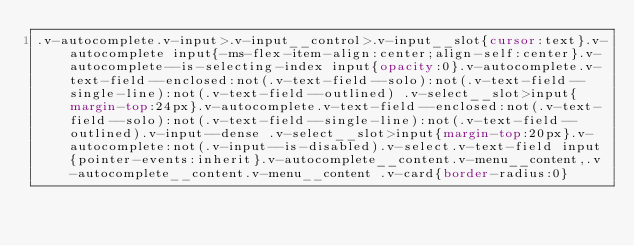Convert code to text. <code><loc_0><loc_0><loc_500><loc_500><_CSS_>.v-autocomplete.v-input>.v-input__control>.v-input__slot{cursor:text}.v-autocomplete input{-ms-flex-item-align:center;align-self:center}.v-autocomplete--is-selecting-index input{opacity:0}.v-autocomplete.v-text-field--enclosed:not(.v-text-field--solo):not(.v-text-field--single-line):not(.v-text-field--outlined) .v-select__slot>input{margin-top:24px}.v-autocomplete.v-text-field--enclosed:not(.v-text-field--solo):not(.v-text-field--single-line):not(.v-text-field--outlined).v-input--dense .v-select__slot>input{margin-top:20px}.v-autocomplete:not(.v-input--is-disabled).v-select.v-text-field input{pointer-events:inherit}.v-autocomplete__content.v-menu__content,.v-autocomplete__content.v-menu__content .v-card{border-radius:0}</code> 